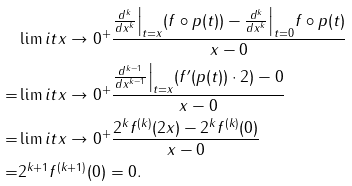Convert formula to latex. <formula><loc_0><loc_0><loc_500><loc_500>& \lim i t { x \to 0 ^ { + } } \frac { \frac { d ^ { k } } { d x ^ { k } } \Big | _ { t = x } ( f \circ p ( t ) ) - \frac { d ^ { k } } { d x ^ { k } } \Big | _ { t = 0 } f \circ p ( t ) } { x - 0 } \\ = & \lim i t { x \to 0 ^ { + } } \frac { \frac { d ^ { k - 1 } } { d x ^ { k - 1 } } \Big | _ { t = x } ( f ^ { \prime } ( p ( t ) ) \cdot 2 ) - 0 } { x - 0 } \\ = & \lim i t { x \to 0 ^ { + } } \frac { 2 ^ { k } f ^ { ( k ) } ( 2 x ) - 2 ^ { k } f ^ { ( k ) } ( 0 ) } { x - 0 } \\ = & 2 ^ { k + 1 } f ^ { ( k + 1 ) } ( 0 ) = 0 .</formula> 